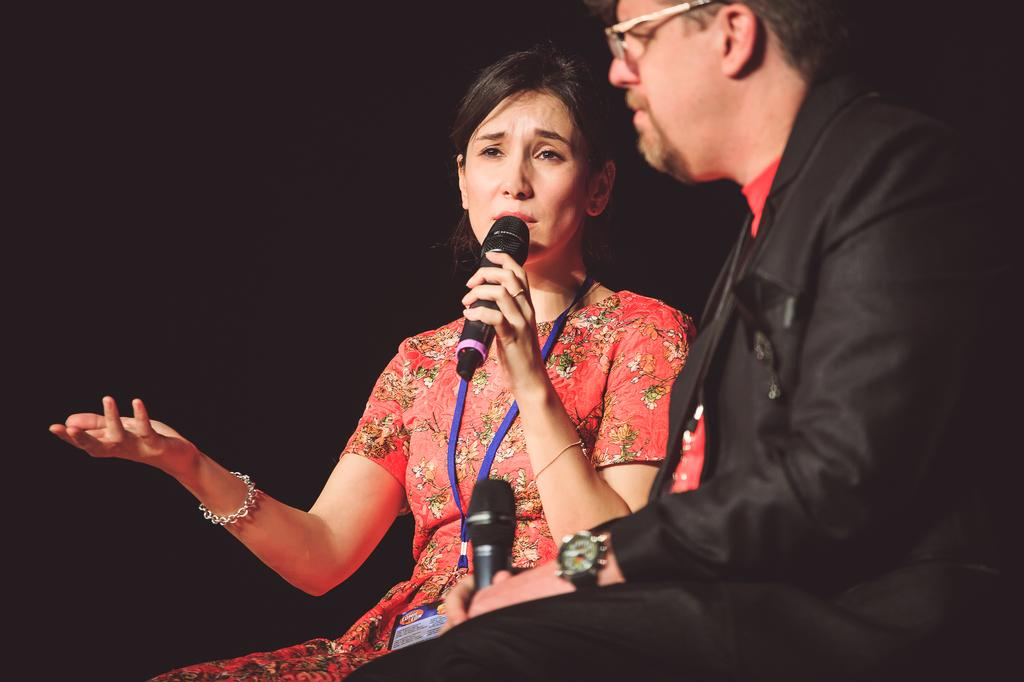How many people are in the image? There are two persons in the image. What are the persons doing in the image? The persons are sitting and holding microphones. What can be observed about the background of the image? The background of the image is dark. What type of line can be seen running through the downtown area in the image? There is no line or downtown area present in the image; it features two persons sitting and holding microphones with a dark background. 